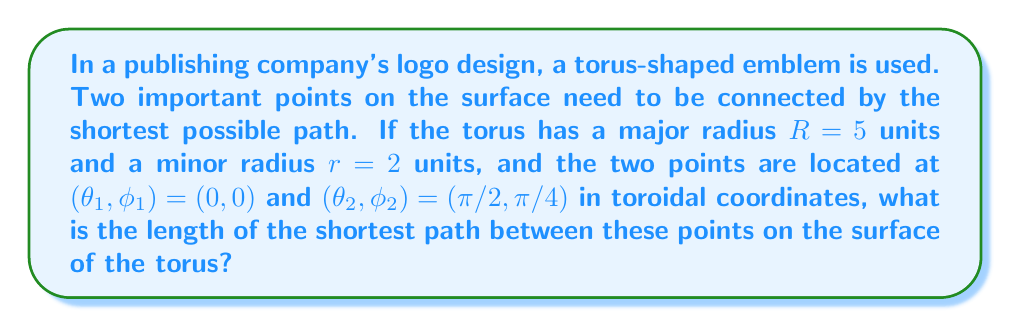Can you answer this question? To solve this problem, we'll follow these steps:

1) The metric for a torus in toroidal coordinates $(\theta, \phi)$ is given by:

   $$ds^2 = (R + r\cos\phi)^2 d\theta^2 + r^2 d\phi^2$$

2) The geodesic equation for a torus is complex, but we can use a simpler approach. The shortest path will be a straight line in the "unwrapped" torus surface.

3) We can "unwrap" the torus into a rectangle with width $2\pi R$ and height $2\pi r$. The points will be at:
   
   $P_1: (0, 0)$ and $P_2: (\frac{\pi}{2}R, \frac{\pi}{4}r)$

4) The distance between these points in the unwrapped torus is:

   $$d = \sqrt{(\frac{\pi}{2}R)^2 + (\frac{\pi}{4}r)^2}$$

5) Substituting the given values:

   $$d = \sqrt{(\frac{\pi}{2} \cdot 5)^2 + (\frac{\pi}{4} \cdot 2)^2}$$

6) Simplifying:

   $$d = \sqrt{(\frac{5\pi}{2})^2 + (\frac{\pi}{2})^2} = \frac{\pi}{2}\sqrt{25 + 1} = \frac{\pi}{2}\sqrt{26}$$

7) Therefore, the length of the shortest path is $\frac{\pi}{2}\sqrt{26}$ units.
Answer: $\frac{\pi}{2}\sqrt{26}$ units 